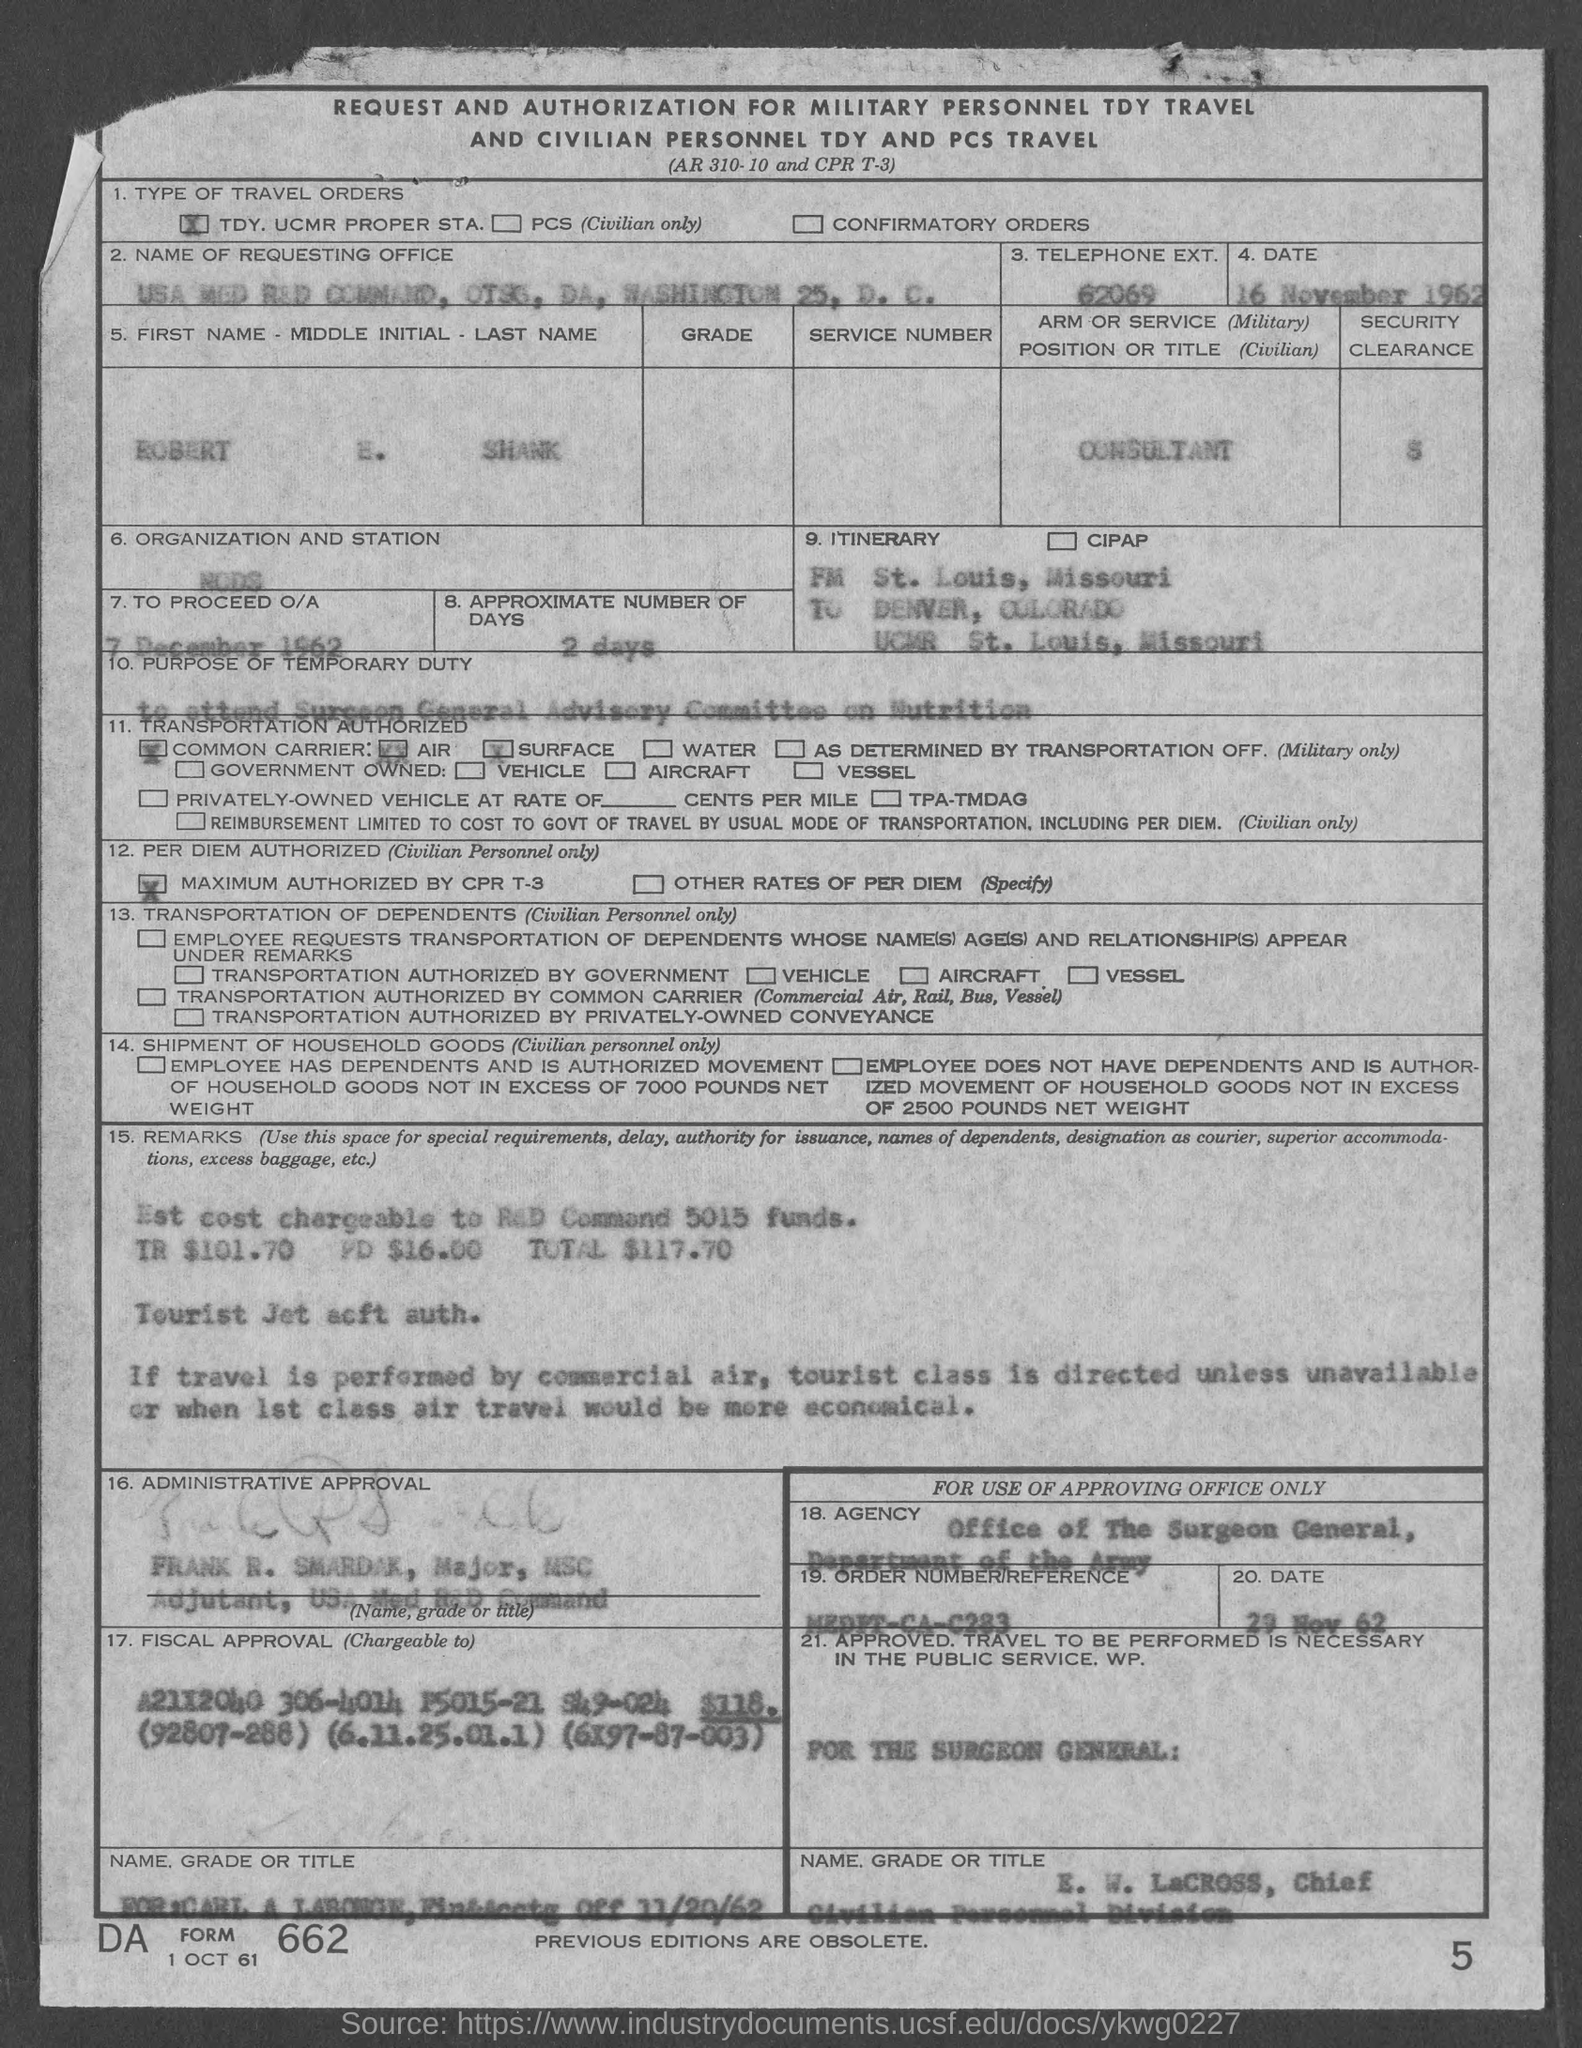What is the telephone ext. no.?
Your answer should be compact. 62069. What is the approximate number of days ?
Provide a succinct answer. 2 days. 